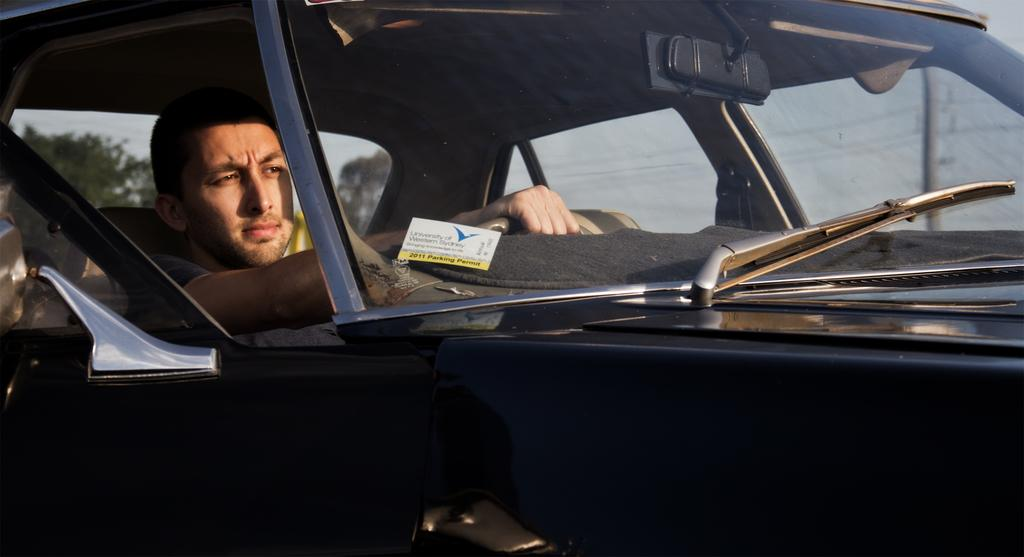What is the main subject of the image? The main subject of the image is a car. Who is operating the car? A person is driving the car. What feature is present on the car to help with visibility during rain or snow? The car has a wiper. What feature is present on the car to help the driver see behind them? The car has a mirror. What is the color of the car in the image? The car is black in color. What type of minister is depicted in the image? There is no minister present in the image; it features a car with a person driving it. What cast of characters can be seen interacting with the car in the image? There are no characters interacting with the car in the image; it only shows the car and a person driving it. 